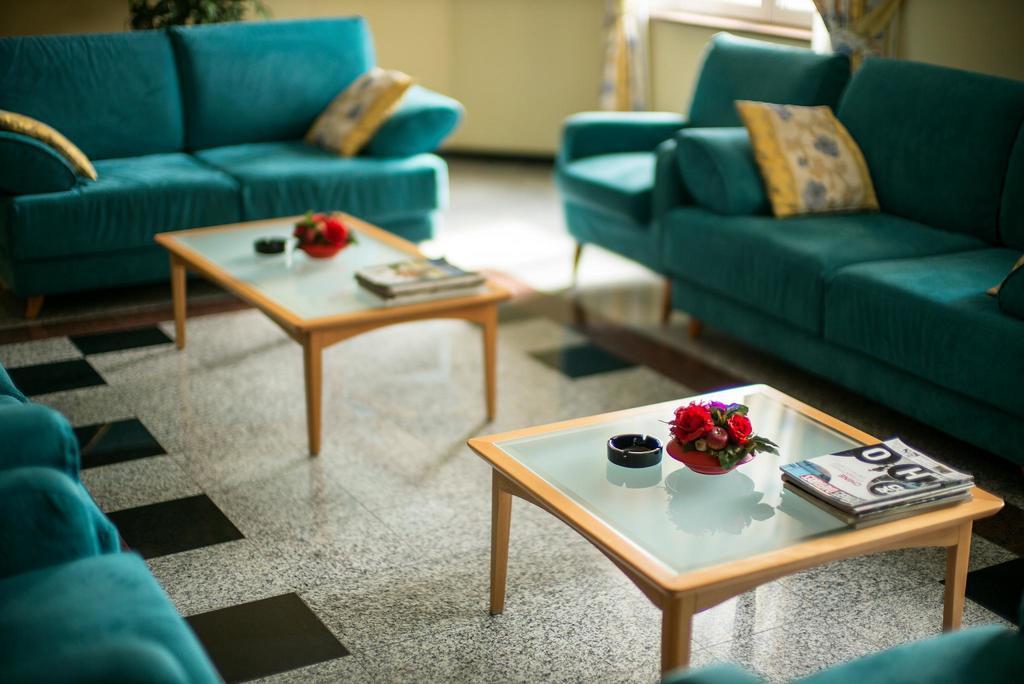Please provide a concise description of this image. This image consists of sofas in blue color. In the middle, there are tables on which flowers and books are kept. At the bottom, there is a floor. In the background, there is a plant along with a wall. 